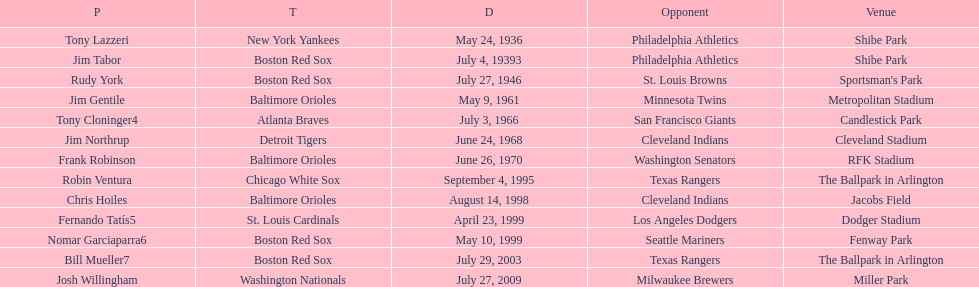Which teams faced off at miller park? Washington Nationals, Milwaukee Brewers. 